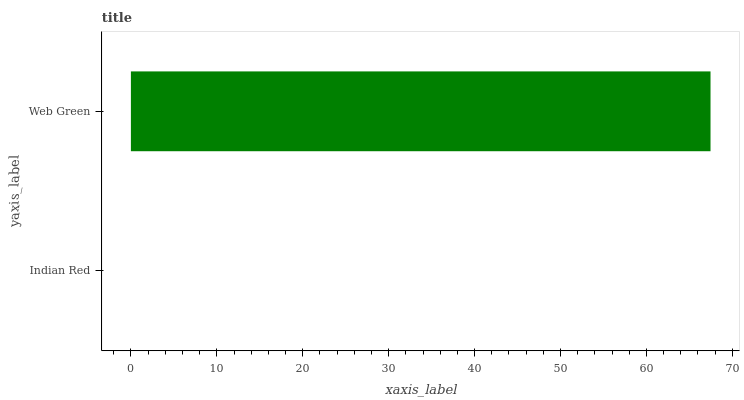Is Indian Red the minimum?
Answer yes or no. Yes. Is Web Green the maximum?
Answer yes or no. Yes. Is Web Green the minimum?
Answer yes or no. No. Is Web Green greater than Indian Red?
Answer yes or no. Yes. Is Indian Red less than Web Green?
Answer yes or no. Yes. Is Indian Red greater than Web Green?
Answer yes or no. No. Is Web Green less than Indian Red?
Answer yes or no. No. Is Web Green the high median?
Answer yes or no. Yes. Is Indian Red the low median?
Answer yes or no. Yes. Is Indian Red the high median?
Answer yes or no. No. Is Web Green the low median?
Answer yes or no. No. 